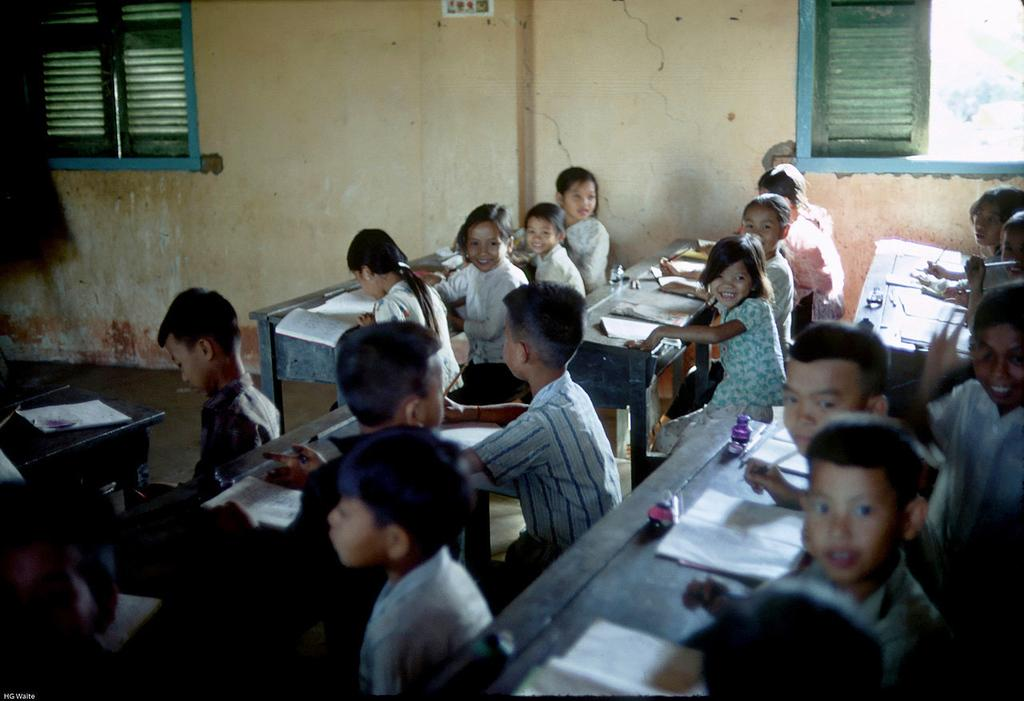What are the kids doing in the image? The kids are sitting on benches in the image. What objects are in front of the kids? There are books in front of the kids. What can be seen in the background of the image? There is a wall in the background of the image. What feature of the wall is mentioned? There are windows in the wall. What type of hope is the minister wearing in the image? There is no minister or apparel mentioned in the image; it only features kids sitting on benches with books in front of them and a wall with windows in the background. 